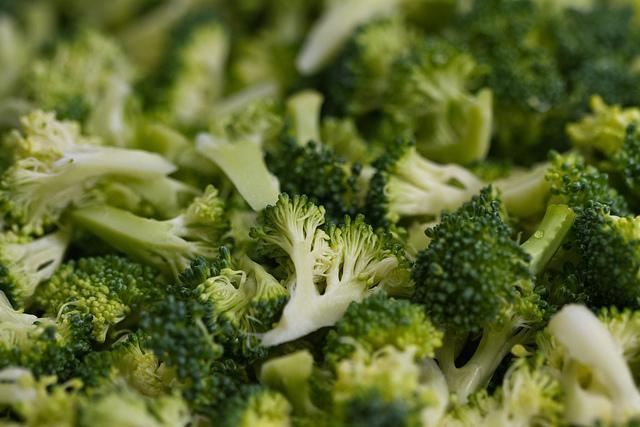How many bugs are in this picture?
Give a very brief answer. 0. How many broccolis can be seen?
Give a very brief answer. 5. How many pizzas are the people holding?
Give a very brief answer. 0. 